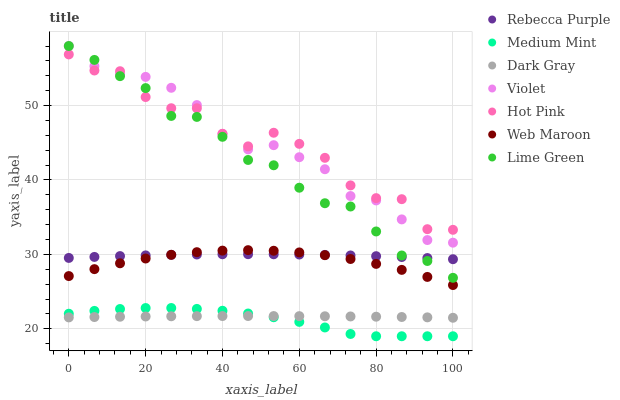Does Medium Mint have the minimum area under the curve?
Answer yes or no. Yes. Does Hot Pink have the maximum area under the curve?
Answer yes or no. Yes. Does Web Maroon have the minimum area under the curve?
Answer yes or no. No. Does Web Maroon have the maximum area under the curve?
Answer yes or no. No. Is Dark Gray the smoothest?
Answer yes or no. Yes. Is Hot Pink the roughest?
Answer yes or no. Yes. Is Web Maroon the smoothest?
Answer yes or no. No. Is Web Maroon the roughest?
Answer yes or no. No. Does Medium Mint have the lowest value?
Answer yes or no. Yes. Does Web Maroon have the lowest value?
Answer yes or no. No. Does Lime Green have the highest value?
Answer yes or no. Yes. Does Hot Pink have the highest value?
Answer yes or no. No. Is Web Maroon less than Violet?
Answer yes or no. Yes. Is Violet greater than Medium Mint?
Answer yes or no. Yes. Does Lime Green intersect Violet?
Answer yes or no. Yes. Is Lime Green less than Violet?
Answer yes or no. No. Is Lime Green greater than Violet?
Answer yes or no. No. Does Web Maroon intersect Violet?
Answer yes or no. No. 